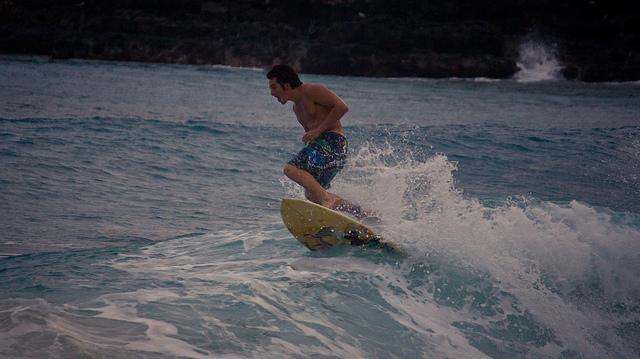What color are the man's shorts?
Write a very short answer. Blue. What is the man wearing?
Concise answer only. Shorts. Why does the man have no shirt on?
Keep it brief. Surfing. Are they wearing wetsuits?
Be succinct. No. What is the surfer wearing?
Short answer required. Shorts. Did he do this on purpose?
Write a very short answer. Yes. What number is on the bottom of the surfboard?
Keep it brief. 0. What is the man doing?
Answer briefly. Surfing. 